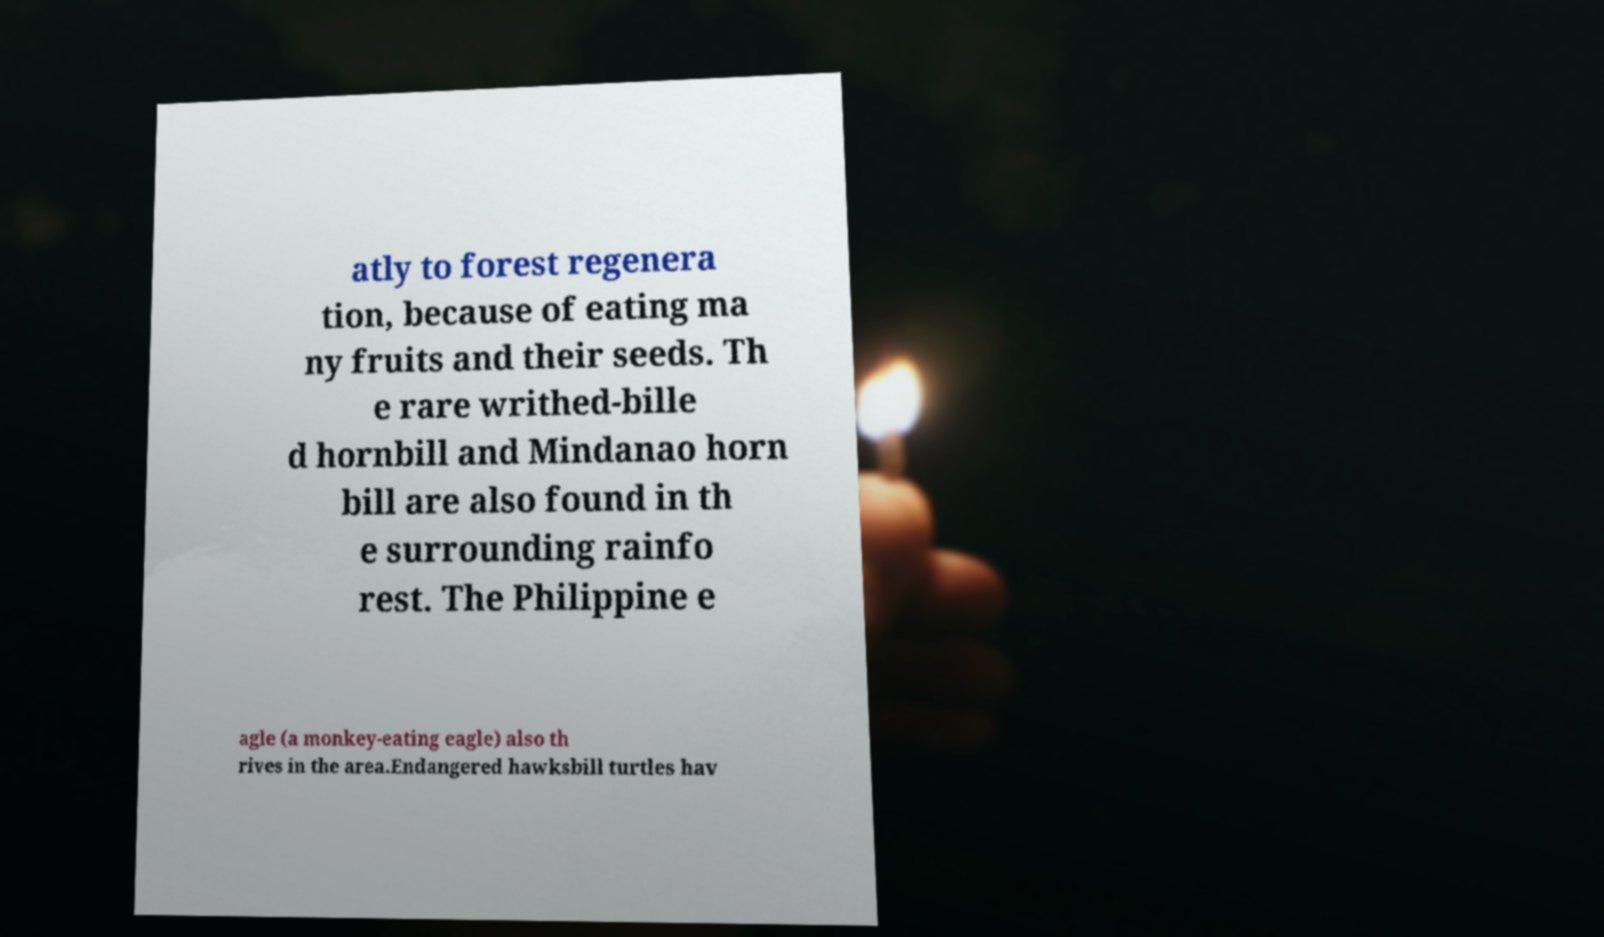I need the written content from this picture converted into text. Can you do that? atly to forest regenera tion, because of eating ma ny fruits and their seeds. Th e rare writhed-bille d hornbill and Mindanao horn bill are also found in th e surrounding rainfo rest. The Philippine e agle (a monkey-eating eagle) also th rives in the area.Endangered hawksbill turtles hav 